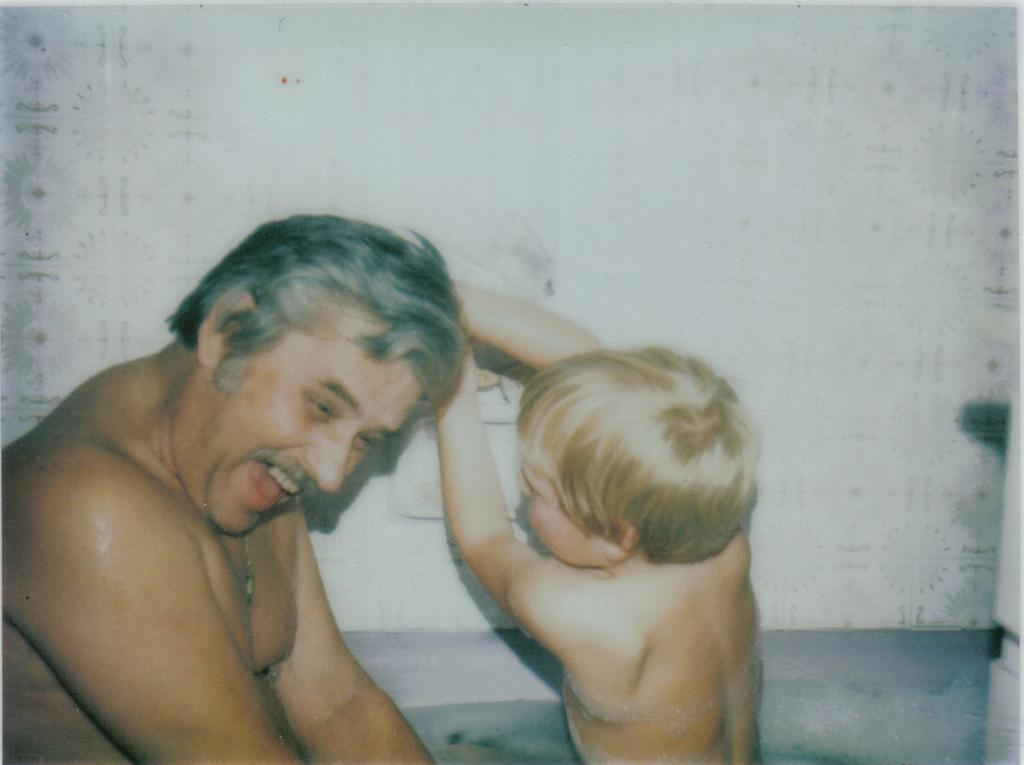Who are the main subjects in the foreground of the image? There is a man and a child in the foreground of the image. What can be seen in the background of the image? The background of the image includes a wall. What type of cast can be seen on the child's arm in the image? There is no cast visible on the child's arm in the image. What type of toothbrush is the man using in the image? There is no toothbrush present in the image. 